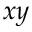Convert formula to latex. <formula><loc_0><loc_0><loc_500><loc_500>x y</formula> 